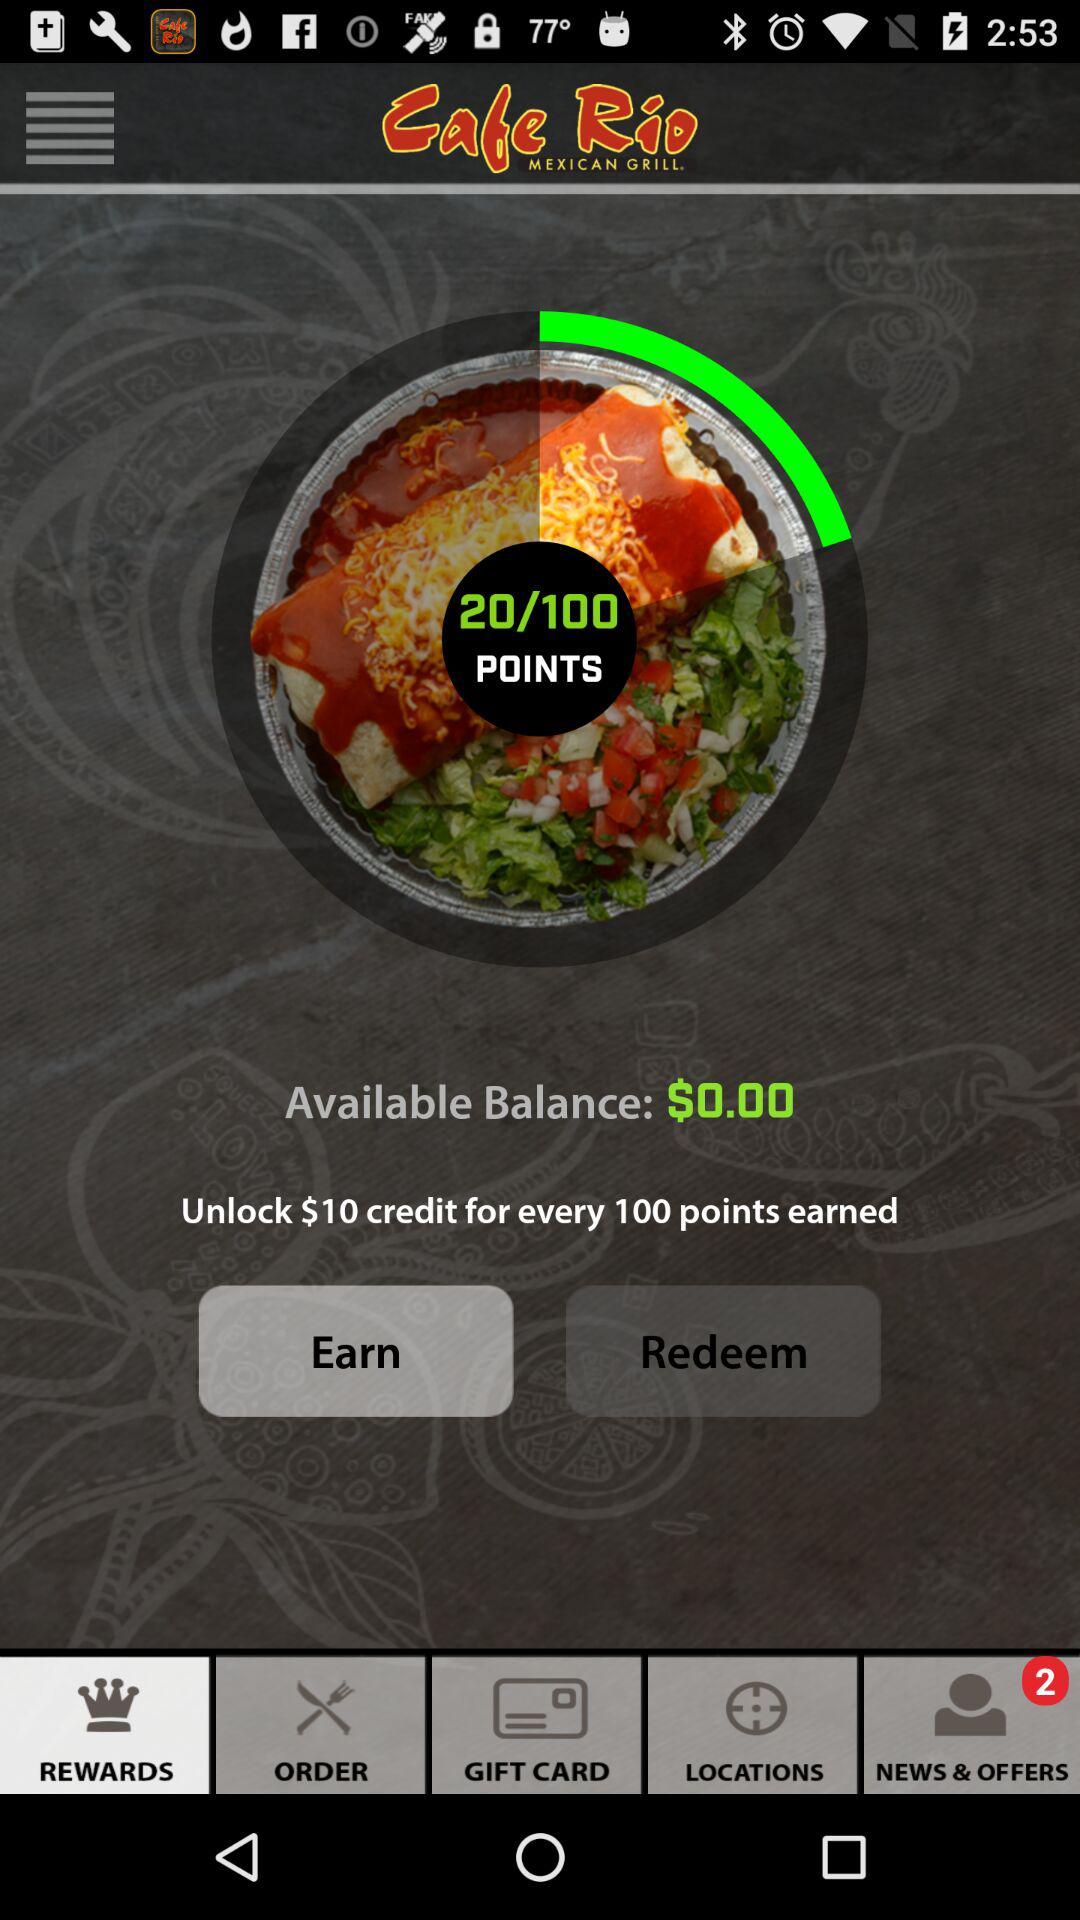How much money do I have in my rewards balance?
Answer the question using a single word or phrase. $0.00 